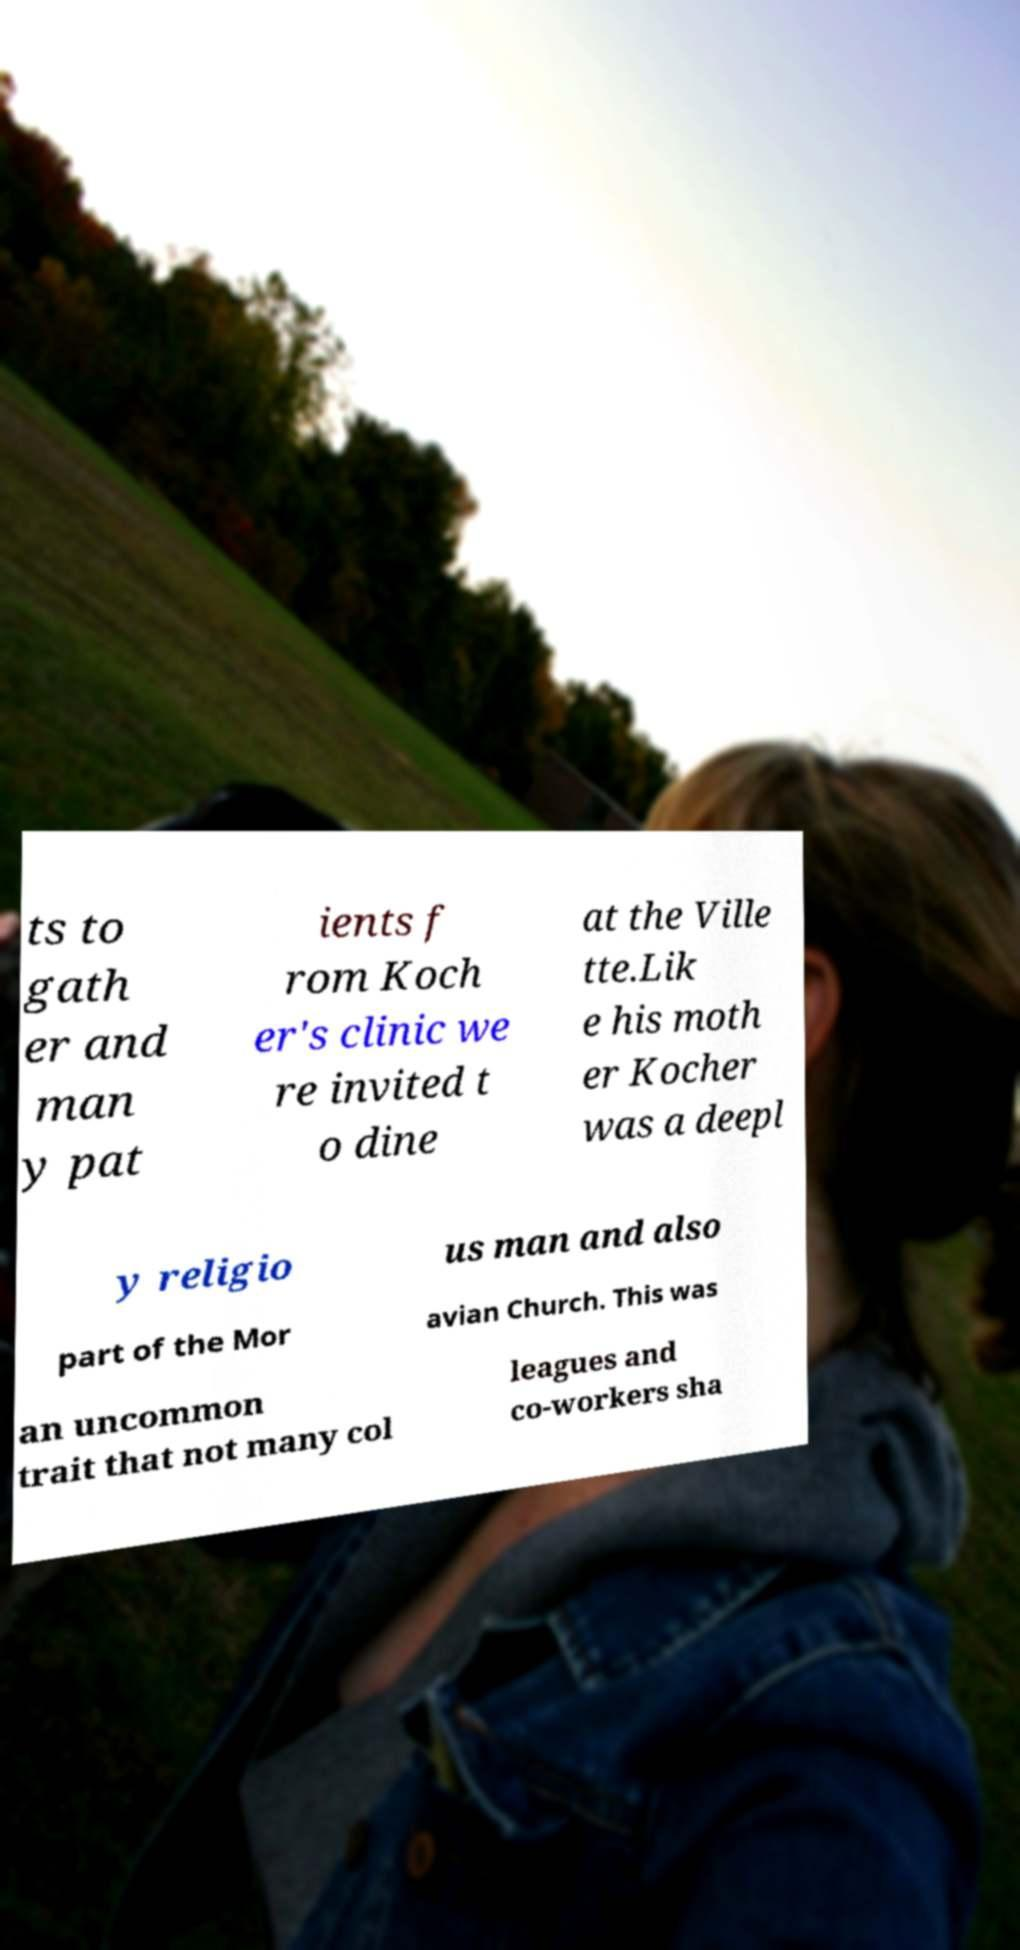Please read and relay the text visible in this image. What does it say? ts to gath er and man y pat ients f rom Koch er's clinic we re invited t o dine at the Ville tte.Lik e his moth er Kocher was a deepl y religio us man and also part of the Mor avian Church. This was an uncommon trait that not many col leagues and co-workers sha 